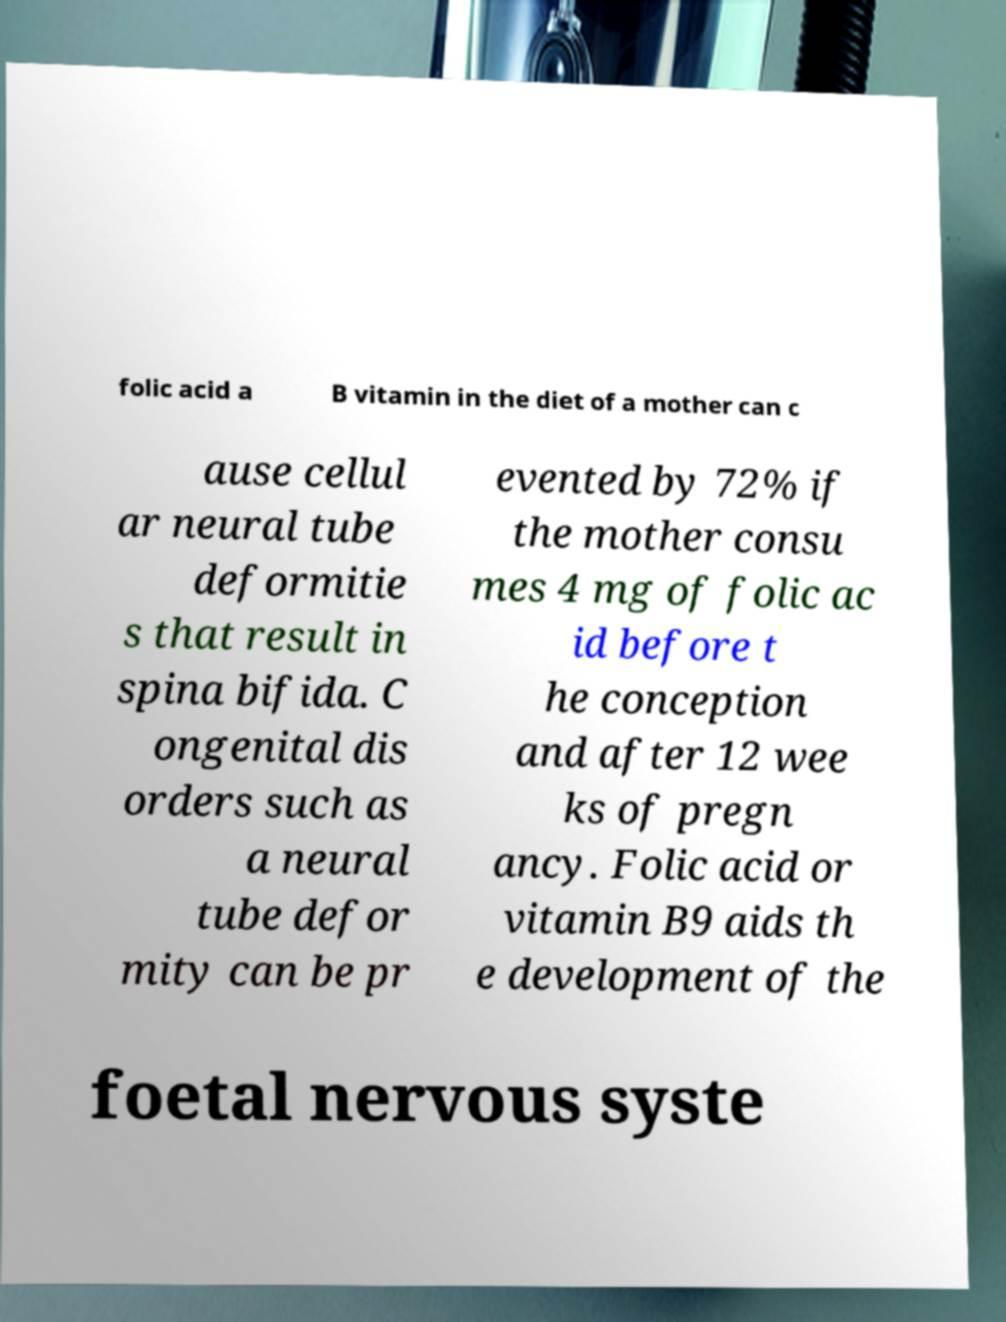Could you extract and type out the text from this image? folic acid a B vitamin in the diet of a mother can c ause cellul ar neural tube deformitie s that result in spina bifida. C ongenital dis orders such as a neural tube defor mity can be pr evented by 72% if the mother consu mes 4 mg of folic ac id before t he conception and after 12 wee ks of pregn ancy. Folic acid or vitamin B9 aids th e development of the foetal nervous syste 